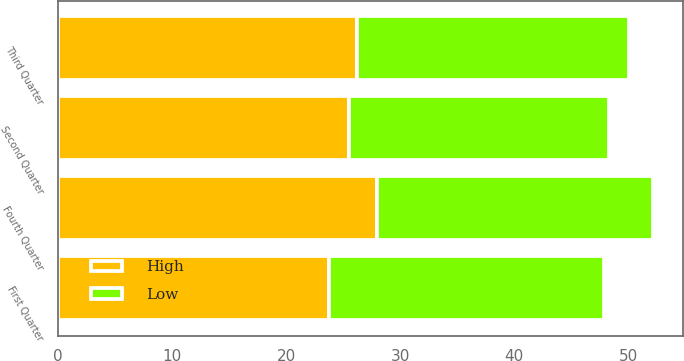<chart> <loc_0><loc_0><loc_500><loc_500><stacked_bar_chart><ecel><fcel>Fourth Quarter<fcel>Third Quarter<fcel>Second Quarter<fcel>First Quarter<nl><fcel>High<fcel>28<fcel>26.24<fcel>25.49<fcel>23.75<nl><fcel>Low<fcel>24.15<fcel>23.83<fcel>22.79<fcel>24.15<nl></chart> 